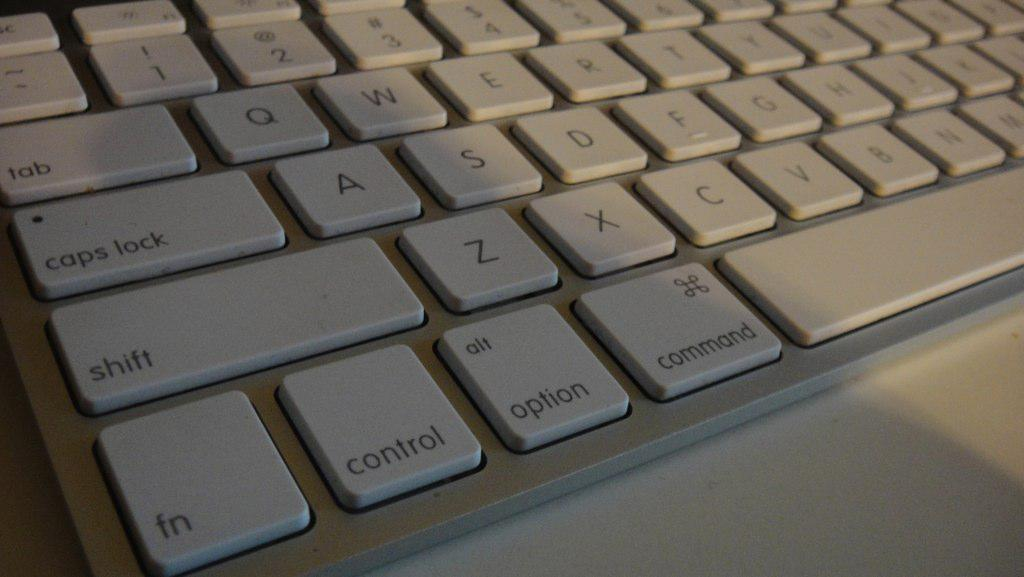<image>
Describe the image concisely. the left bottom corner of a keyboard with the control and option buttons 